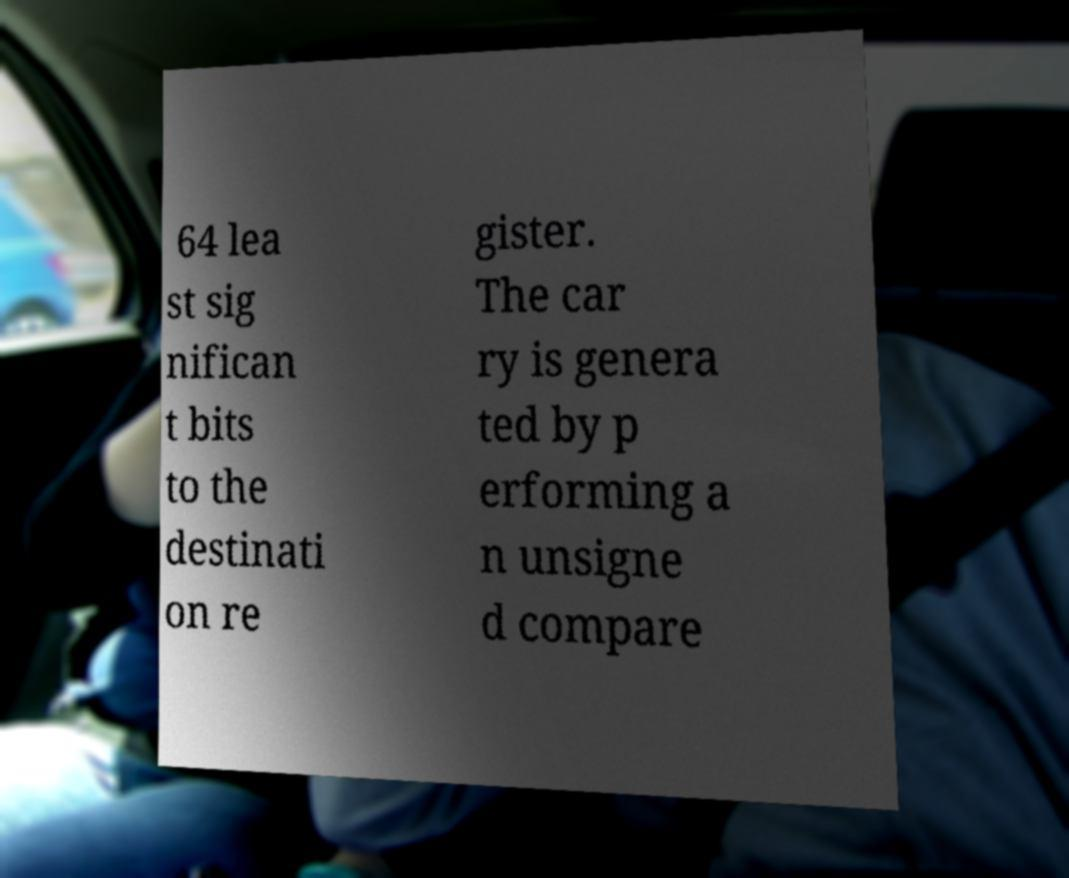Could you extract and type out the text from this image? 64 lea st sig nifican t bits to the destinati on re gister. The car ry is genera ted by p erforming a n unsigne d compare 